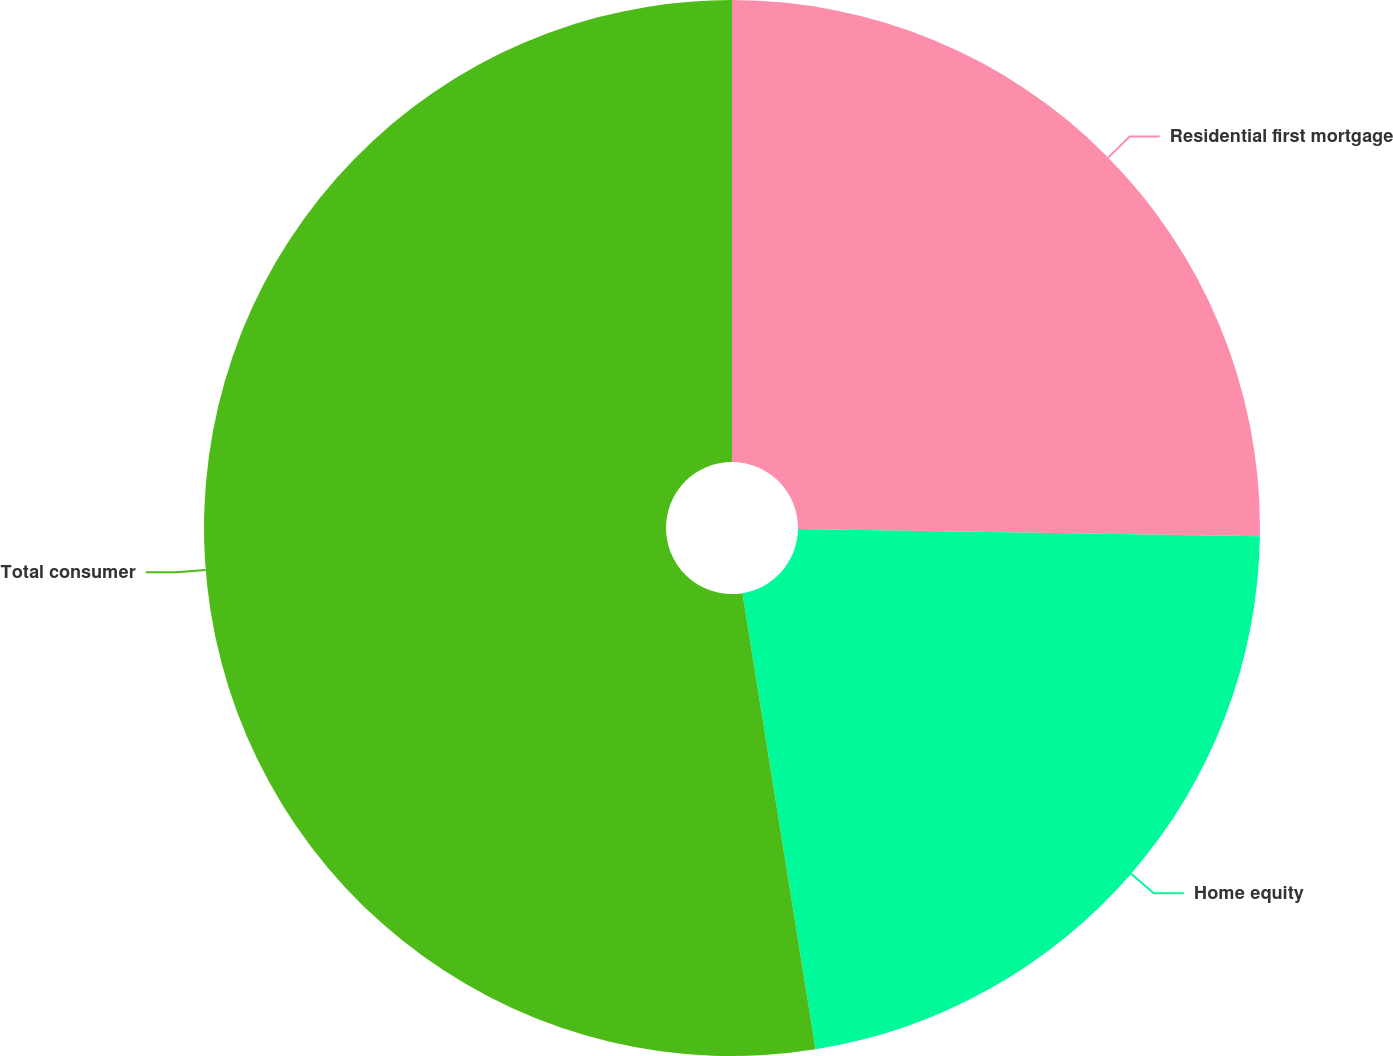<chart> <loc_0><loc_0><loc_500><loc_500><pie_chart><fcel>Residential first mortgage<fcel>Home equity<fcel>Total consumer<nl><fcel>25.25%<fcel>22.22%<fcel>52.53%<nl></chart> 